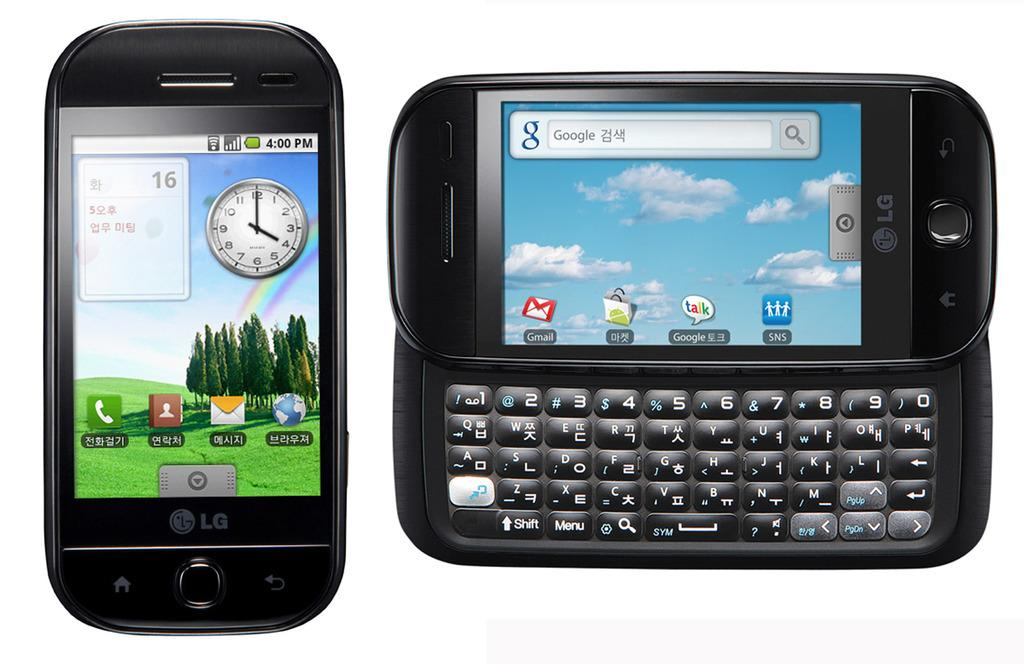<image>
Give a short and clear explanation of the subsequent image. Two cell phones that say LG are open to the home screen. 